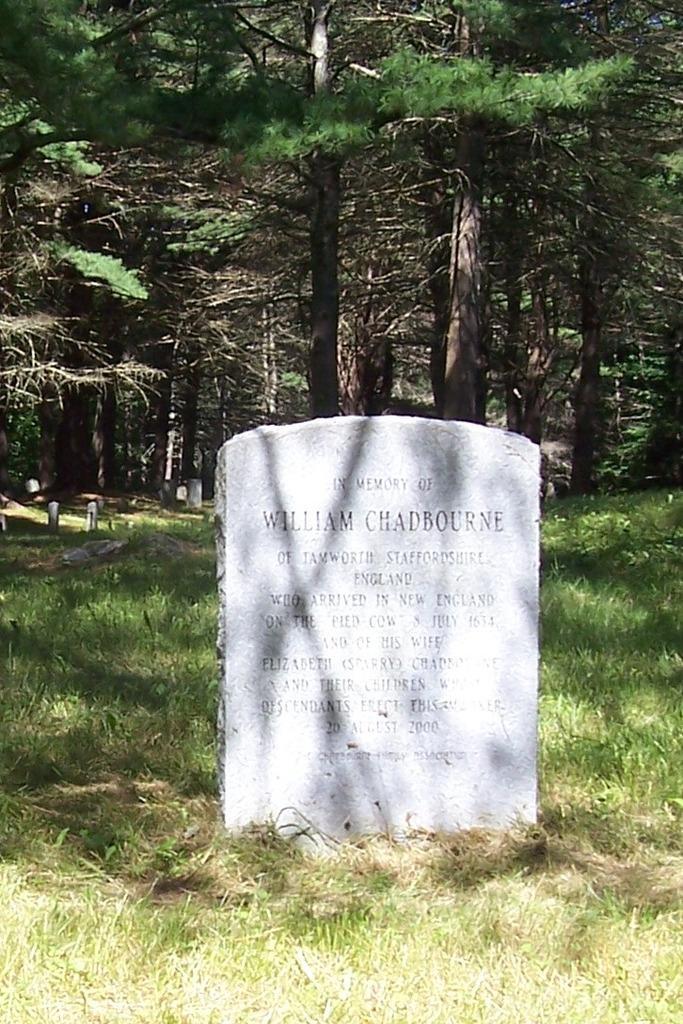How would you summarize this image in a sentence or two? In the picture we can see the grass surface on it, we can see the gravestone with some information and behind it we can see the trees. 